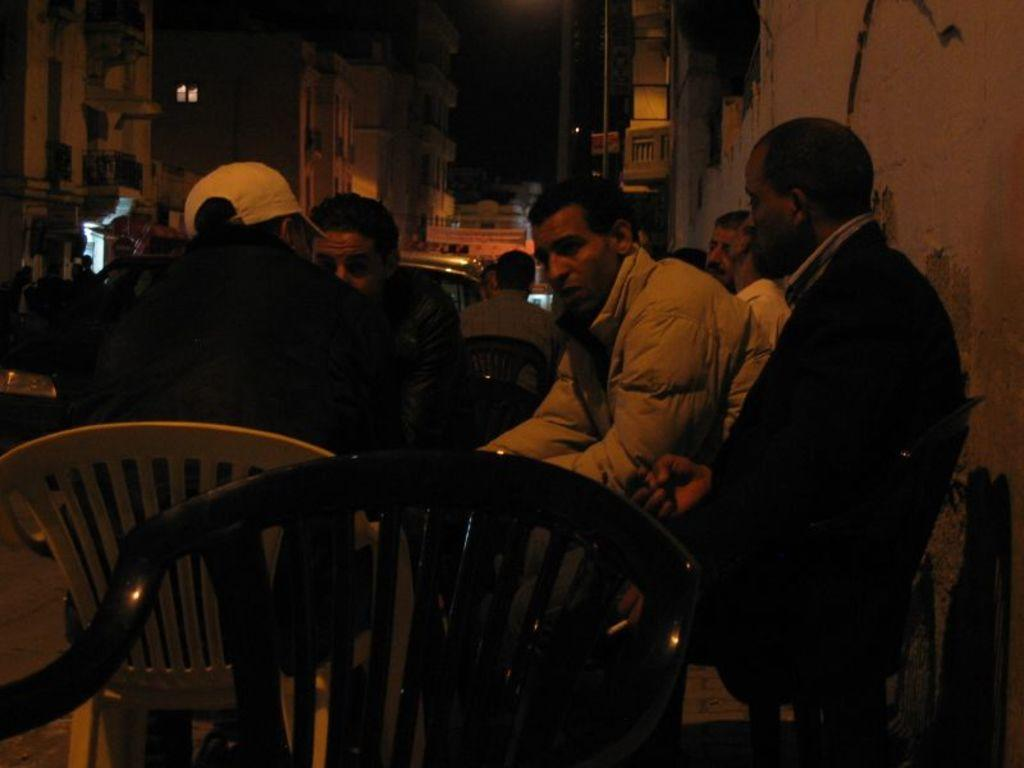How many people are in the image? There are four people in the image. What are the people doing in the image? The people are sitting at a table. Where was the image taken? The image was taken on a road. What can be seen in the background of the image? There are vehicles and buildings visible in the background of the image. What color is the eye of the person sitting at the table? There is no mention of an eye or any specific person in the image, so we cannot determine the color of an eye. 